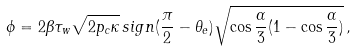<formula> <loc_0><loc_0><loc_500><loc_500>\phi = 2 \beta \tau _ { w } \sqrt { 2 p _ { c } \kappa } \, s i g n ( \frac { \pi } { 2 } - \theta _ { e } ) \sqrt { \cos { \frac { \alpha } { 3 } } ( 1 - \cos { \frac { \alpha } { 3 } } ) } \, ,</formula> 